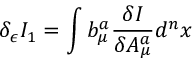<formula> <loc_0><loc_0><loc_500><loc_500>\delta _ { \epsilon } I _ { 1 } = \int b _ { \mu } ^ { a } \frac { \delta I } { \delta A _ { \mu } ^ { a } } d ^ { n } x</formula> 